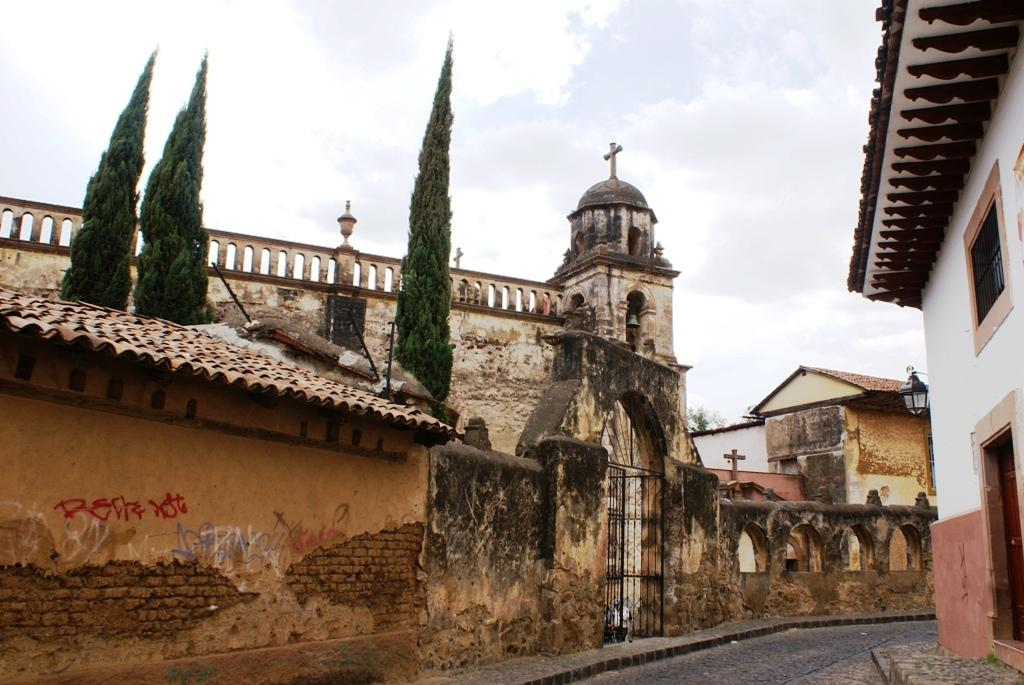What type of structures can be seen in the image? There are buildings in the image. What feature is common among the buildings? There are windows in the image. What is the color of the gate in the image? The gate in the image is black in color. What type of vegetation is present in the image? There are trees in the image. What can be seen illuminating the area in the image? There is a light visible in the image. What is the color of the sky in the image? The sky is blue and white in color. How many goldfish are swimming in the light in the image? There are no goldfish present in the image; the light is illuminating the area without any goldfish. What type of lamp is used to provide the light in the image? There is no lamp mentioned or visible in the image; the light source is not specified. 